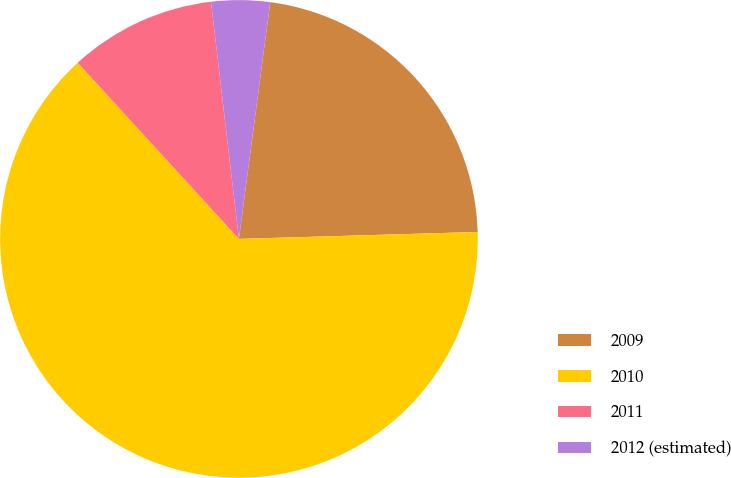<chart> <loc_0><loc_0><loc_500><loc_500><pie_chart><fcel>2009<fcel>2010<fcel>2011<fcel>2012 (estimated)<nl><fcel>22.44%<fcel>63.66%<fcel>9.93%<fcel>3.96%<nl></chart> 